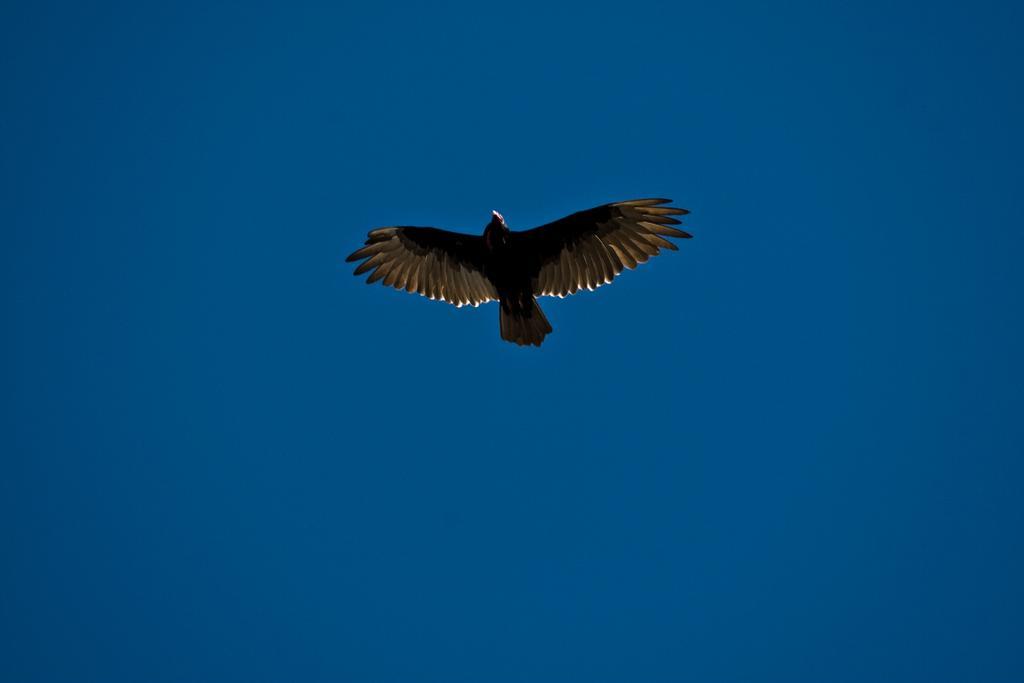How would you summarize this image in a sentence or two? In this image, I can see a bird flying. In the background, there is the sky. 